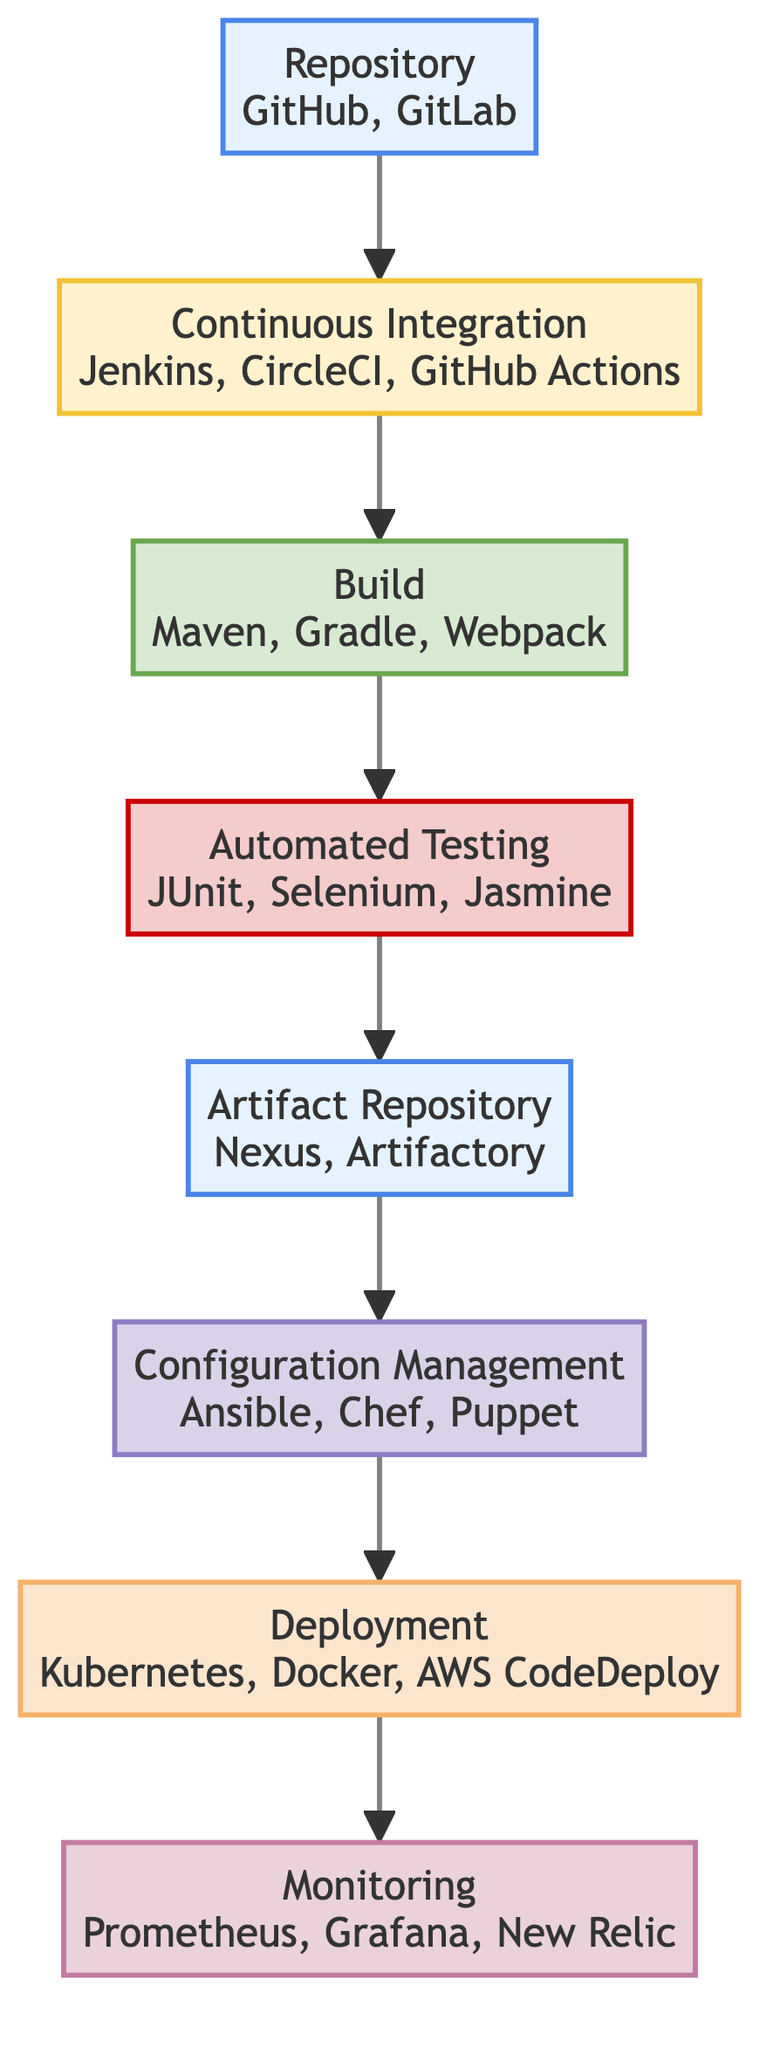What is the first step in the deployment pipeline? The first step in the pipeline is the "Repository," where the code is stored in a version-controlled system. This is indicated at the bottom of the flowchart, which shows the initial point of the process.
Answer: Repository How many entities are listed under "Monitoring"? There are three entities listed under "Monitoring," which are Prometheus, Grafana, and New Relic. These are indicated as part of the "Monitoring" node in the flowchart.
Answer: 3 What process follows the "Automated Testing" stage? The process that follows the "Automated Testing" stage is "Artifact Repository." This can be traced in the flow from bottom to top, where the arrow indicates the flow between the two nodes.
Answer: Artifact Repository Which node is responsible for managing environment configurations? The "Configuration Management" node is responsible for managing environment configurations for different stages, as shown in the flowchart linking to the Deployment process.
Answer: Configuration Management What type of node is "Deployment"? The "Deployment" node is categorized as an "Execution" type. This classification is highlighted in the flowchart, distinguishing it from other types of nodes.
Answer: Execution After "Build," which stage is focused on quality assurance? The stage focused on quality assurance after "Build" is "Automated Testing." This can be determined by following the arrows upward from the "Build" node in the flowchart.
Answer: Automated Testing How does the "Artifact Repository" relate to "Deployment"? The "Artifact Repository" is directly linked to the "Deployment" node, indicating that the artifacts stored in the repository are the ones deployed to the specified environments. This relationship is shown by the arrow connecting the two nodes.
Answer: Directly linked What is the last stage in the deployment pipeline? The last stage in the deployment pipeline is the "Monitoring" stage. It is positioned at the top of the flowchart, indicating that monitoring is the ultimate goal after deployment.
Answer: Monitoring 